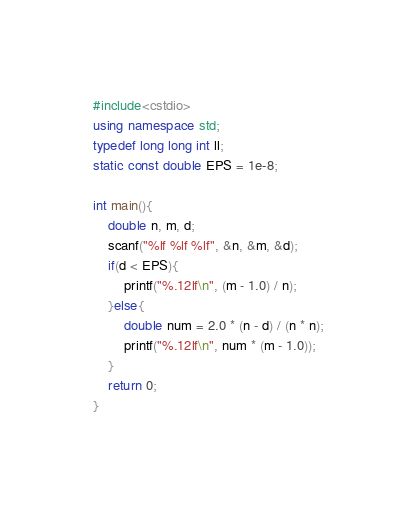<code> <loc_0><loc_0><loc_500><loc_500><_C++_>#include<cstdio>
using namespace std;
typedef long long int ll;
static const double EPS = 1e-8;

int main(){
	double n, m, d;
	scanf("%lf %lf %lf", &n, &m, &d);
	if(d < EPS){
		printf("%.12lf\n", (m - 1.0) / n);
	}else{
		double num = 2.0 * (n - d) / (n * n);
      	printf("%.12lf\n", num * (m - 1.0));
	}
	return 0;
}
</code> 